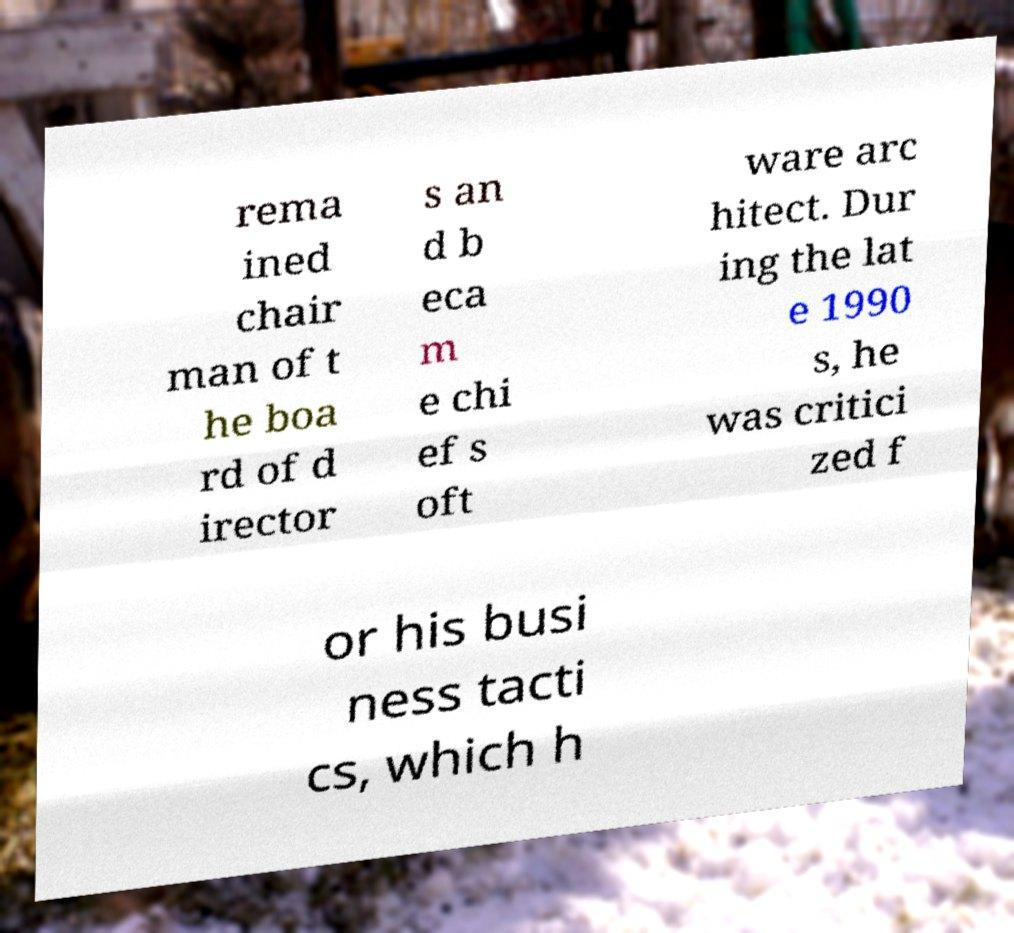For documentation purposes, I need the text within this image transcribed. Could you provide that? rema ined chair man of t he boa rd of d irector s an d b eca m e chi ef s oft ware arc hitect. Dur ing the lat e 1990 s, he was critici zed f or his busi ness tacti cs, which h 